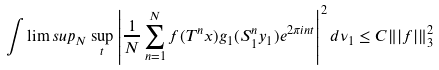<formula> <loc_0><loc_0><loc_500><loc_500>\int \lim s u p _ { N } \sup _ { t } \left | \frac { 1 } { N } \sum _ { n = 1 } ^ { N } f ( T ^ { n } x ) g _ { 1 } ( S _ { 1 } ^ { n } y _ { 1 } ) e ^ { 2 \pi i n t } \right | ^ { 2 } d \nu _ { 1 } \leq C \| | f | \| _ { 3 } ^ { 2 }</formula> 